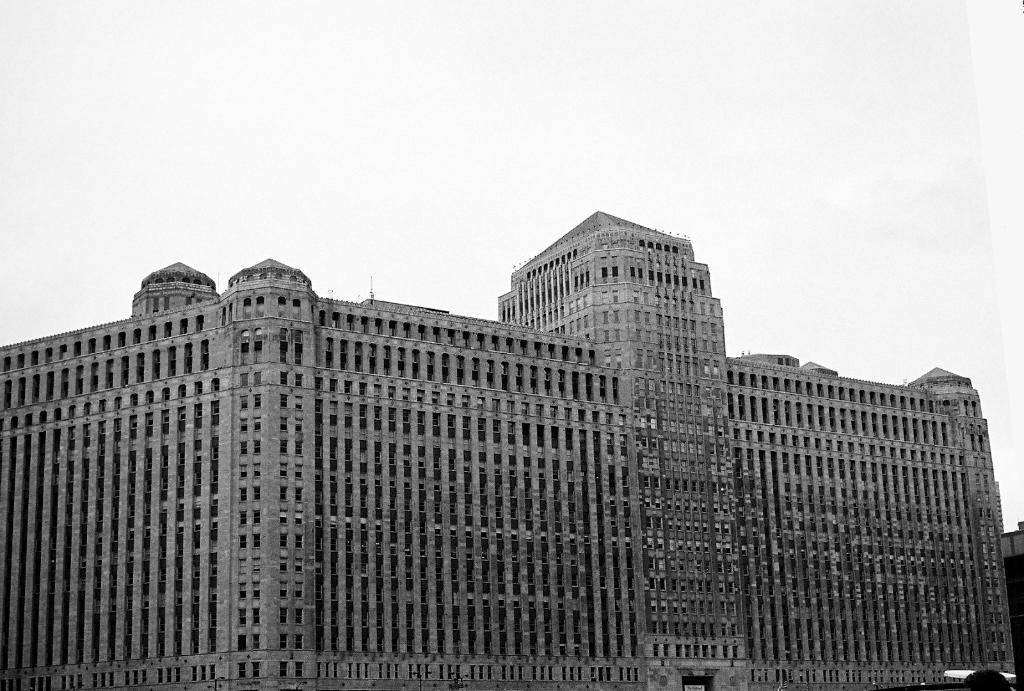What structure is present in the image? There is a building in the image. What else can be seen in the image besides the building? The sky is visible in the image. How would you describe the sky in the image? The sky appears to be cloudy. What time of day is it in the image, and how can you tell? The provided facts do not mention the time of day, and there is no information in the image to determine the time. 